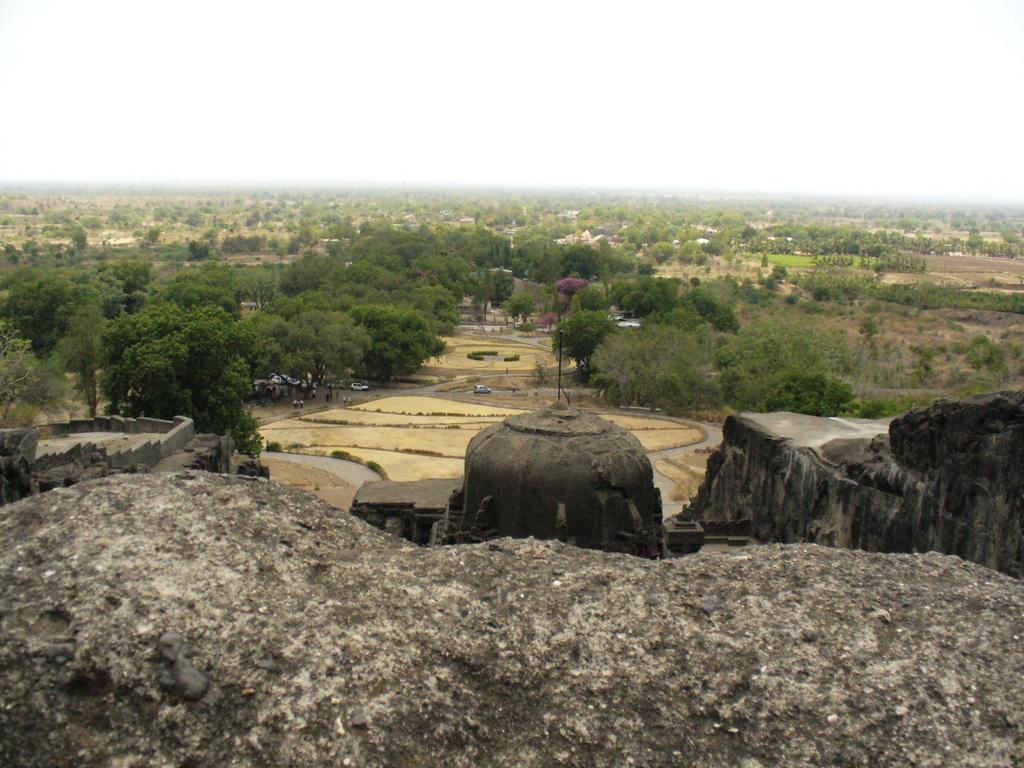How would you summarize this image in a sentence or two? In this image I can see trees and rocks. In the background I can see the sky. 